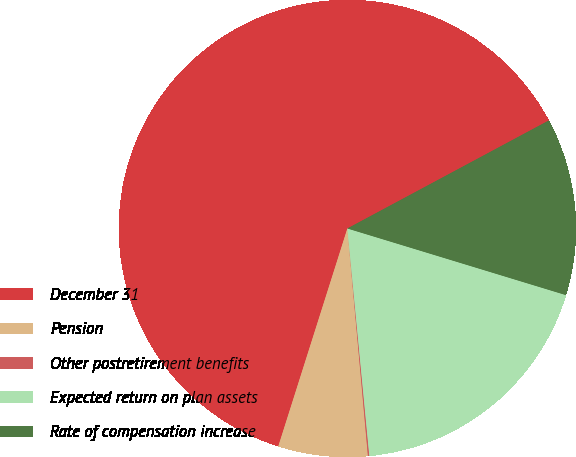Convert chart to OTSL. <chart><loc_0><loc_0><loc_500><loc_500><pie_chart><fcel>December 31<fcel>Pension<fcel>Other postretirement benefits<fcel>Expected return on plan assets<fcel>Rate of compensation increase<nl><fcel>62.28%<fcel>6.32%<fcel>0.1%<fcel>18.76%<fcel>12.54%<nl></chart> 